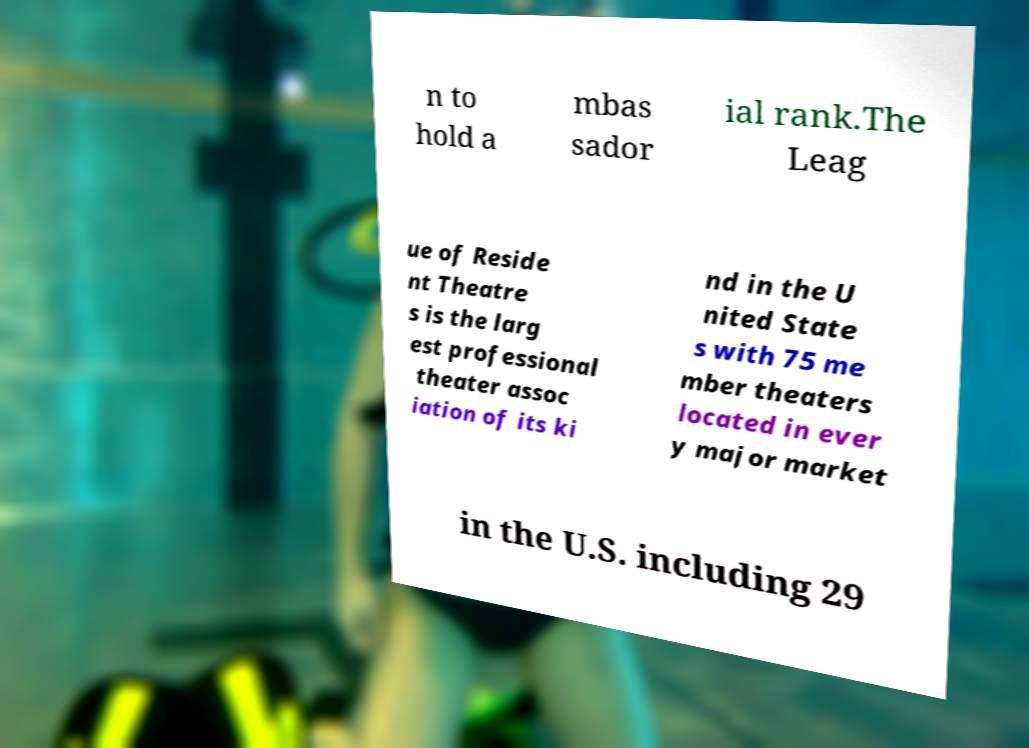There's text embedded in this image that I need extracted. Can you transcribe it verbatim? n to hold a mbas sador ial rank.The Leag ue of Reside nt Theatre s is the larg est professional theater assoc iation of its ki nd in the U nited State s with 75 me mber theaters located in ever y major market in the U.S. including 29 